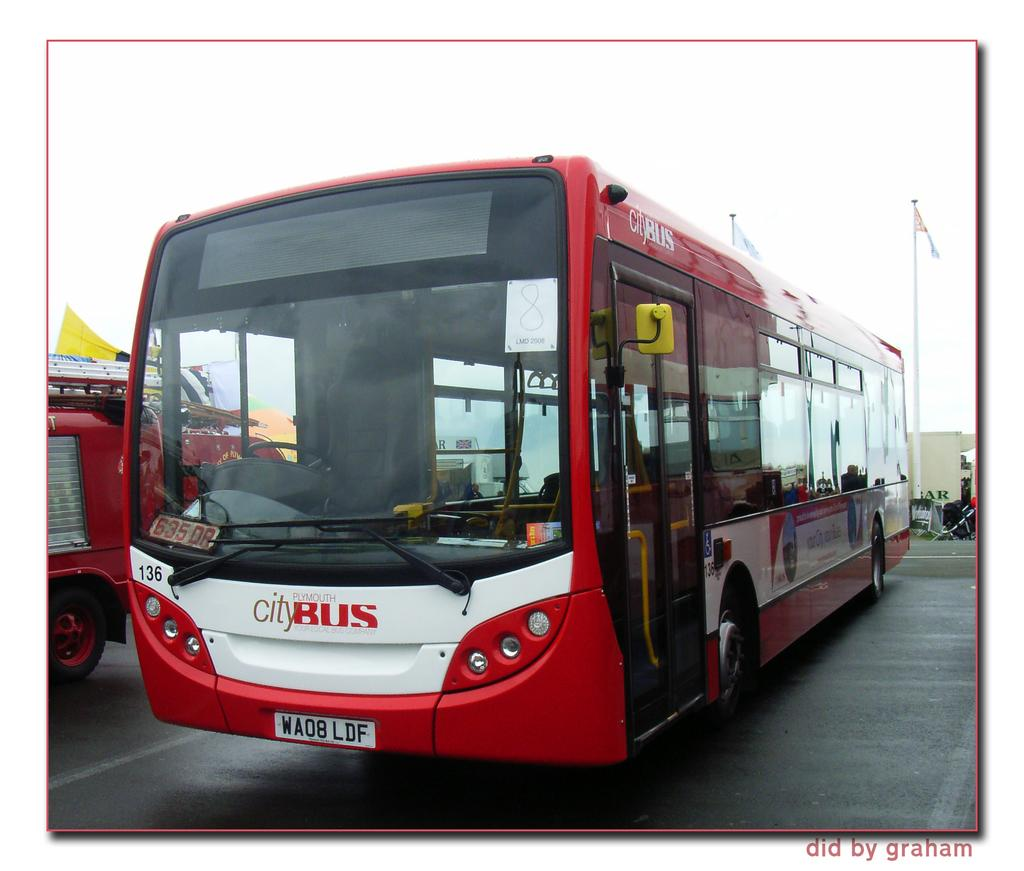<image>
Share a concise interpretation of the image provided. A red Plymouth city bus is parked in a lot. 